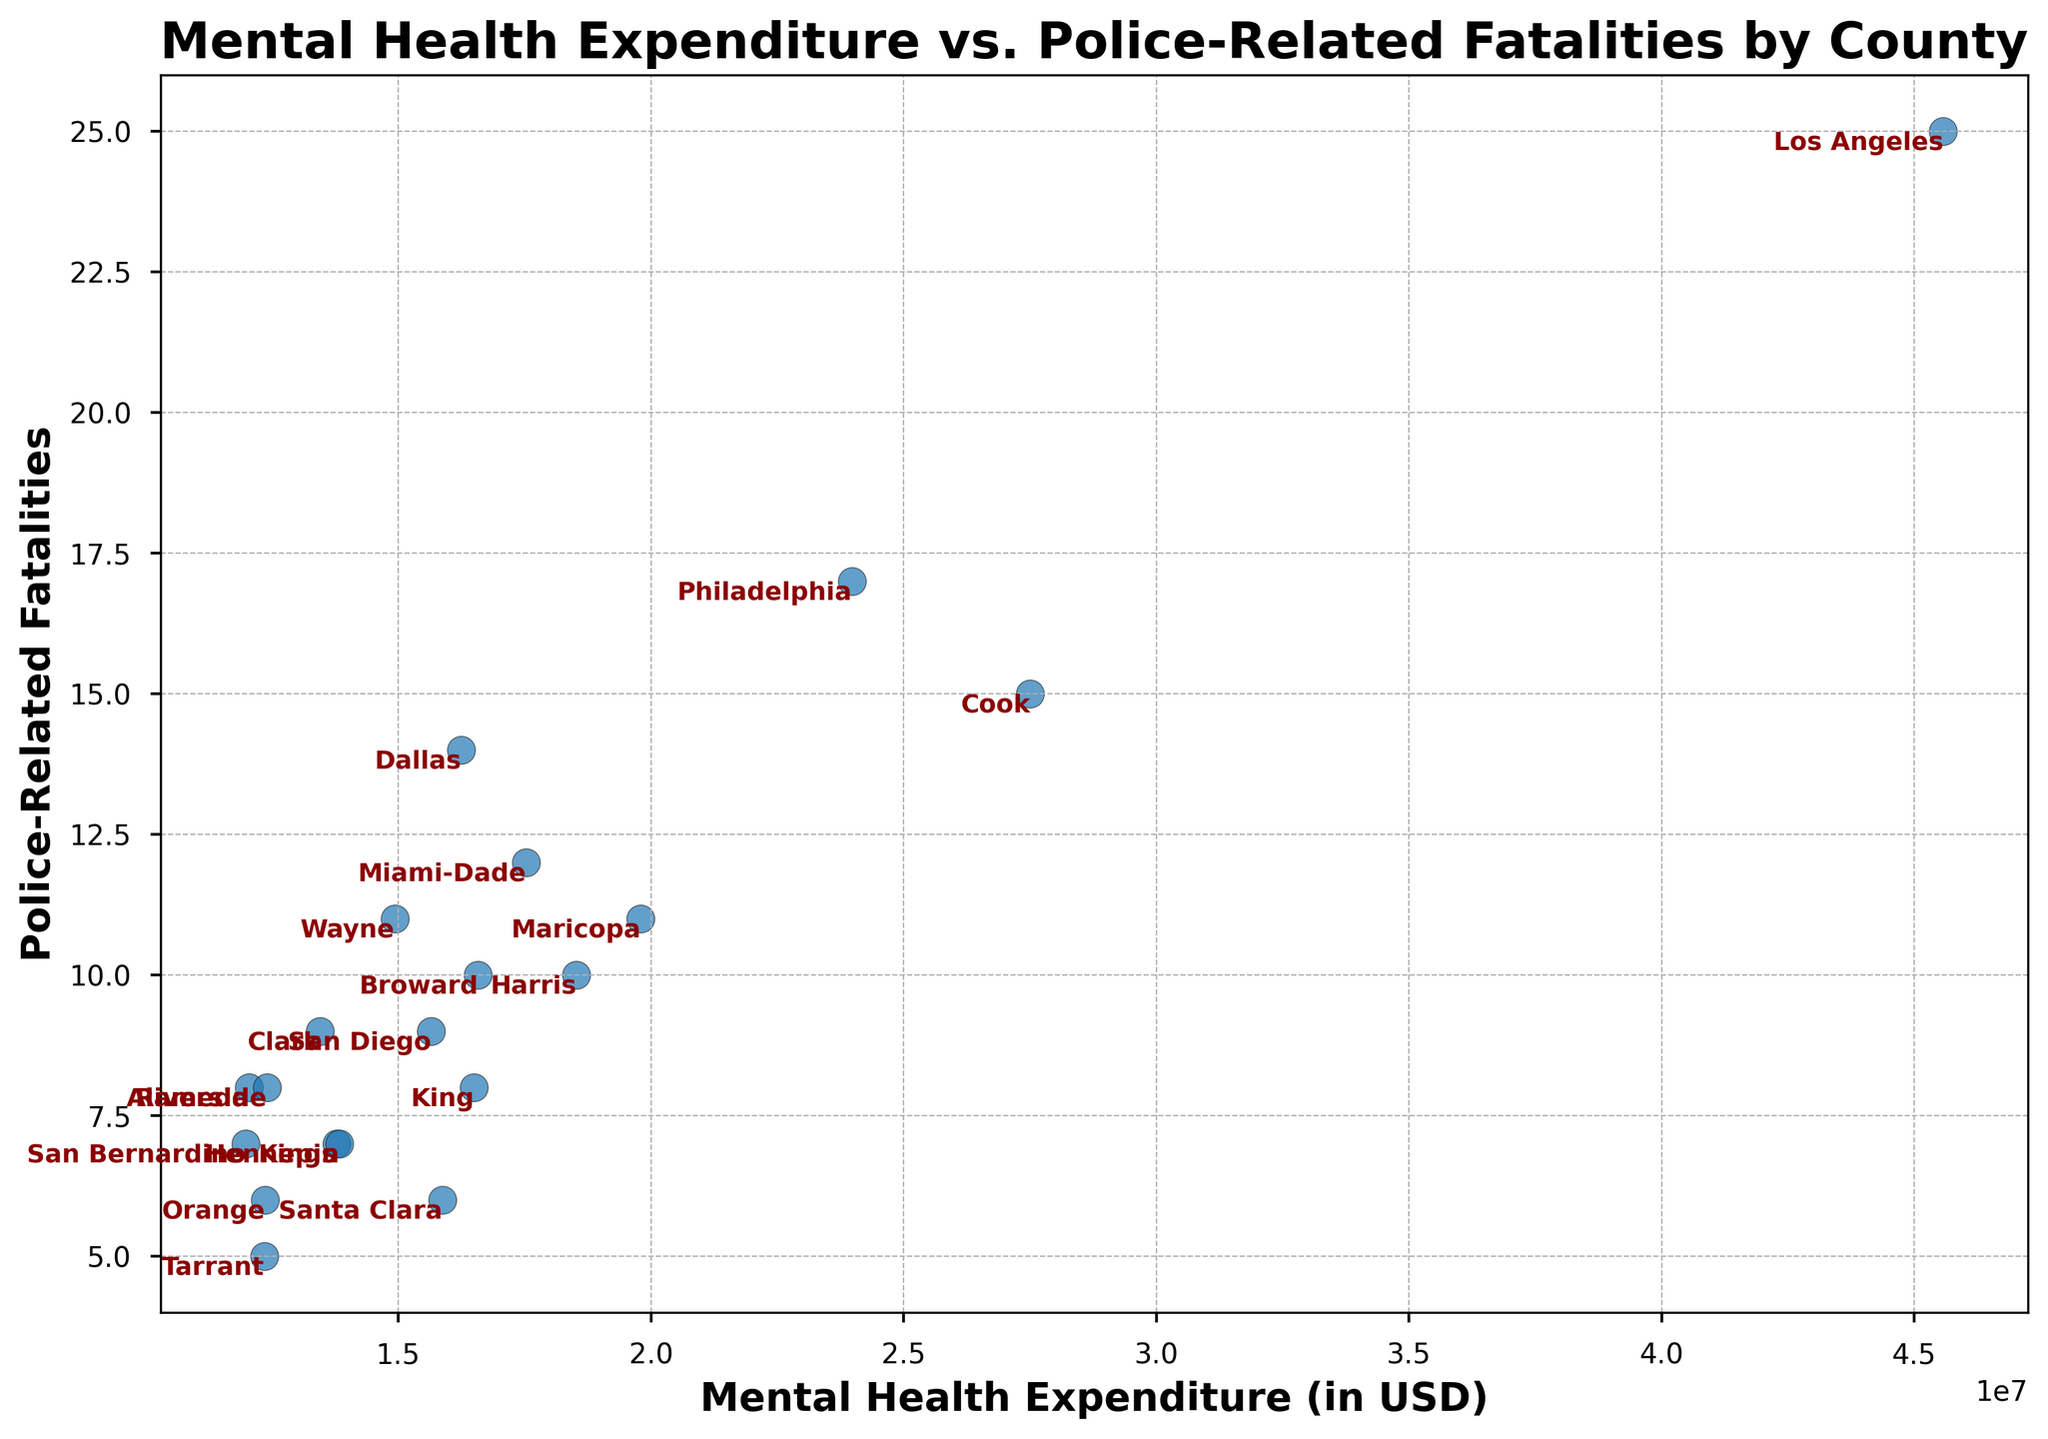What county has the highest Mental Health Expenditure? To find the county with the highest Mental Health Expenditure, look for the data point farthest to the right. From the figure, it’s “Los Angeles” with a Mental Health Expenditure of $45,570,000.
Answer: Los Angeles Which county experiences the highest number of Police-Related Fatalities? To find the county with the highest Police-Related Fatalities, look for the data point vertical position that’s the highest. Philadelphia has the highest with 17 fatalities.
Answer: Philadelphia Is there a county where Mental Health Expenditure and Police-Related Fatalities have equal values? Check if any data point lines up on the line y = x in the scatter plot, where the expenditures and fatalities are equal. No county exhibits this relationship in the figure.
Answer: No Among the counties with less than $20,000,000 in Mental Health Expenditure, which one has the most Police-Related Fatalities? First, filter the counties that have Mental Health Expenditure less than $20,000,000, and then look for the highest vertical position within them. The county is Wayne with 11 fatalities.
Answer: Wayne What is the combined number of Police-Related Fatalities for the counties in California? Sum the fatalities for counties from California: Alameda (8), Los Angeles (25), San Diego (9), Orange (6), Riverside (8), San Bernardino (7). The total is 8 + 25 + 9 + 6 + 8 + 7 = 63.
Answer: 63 